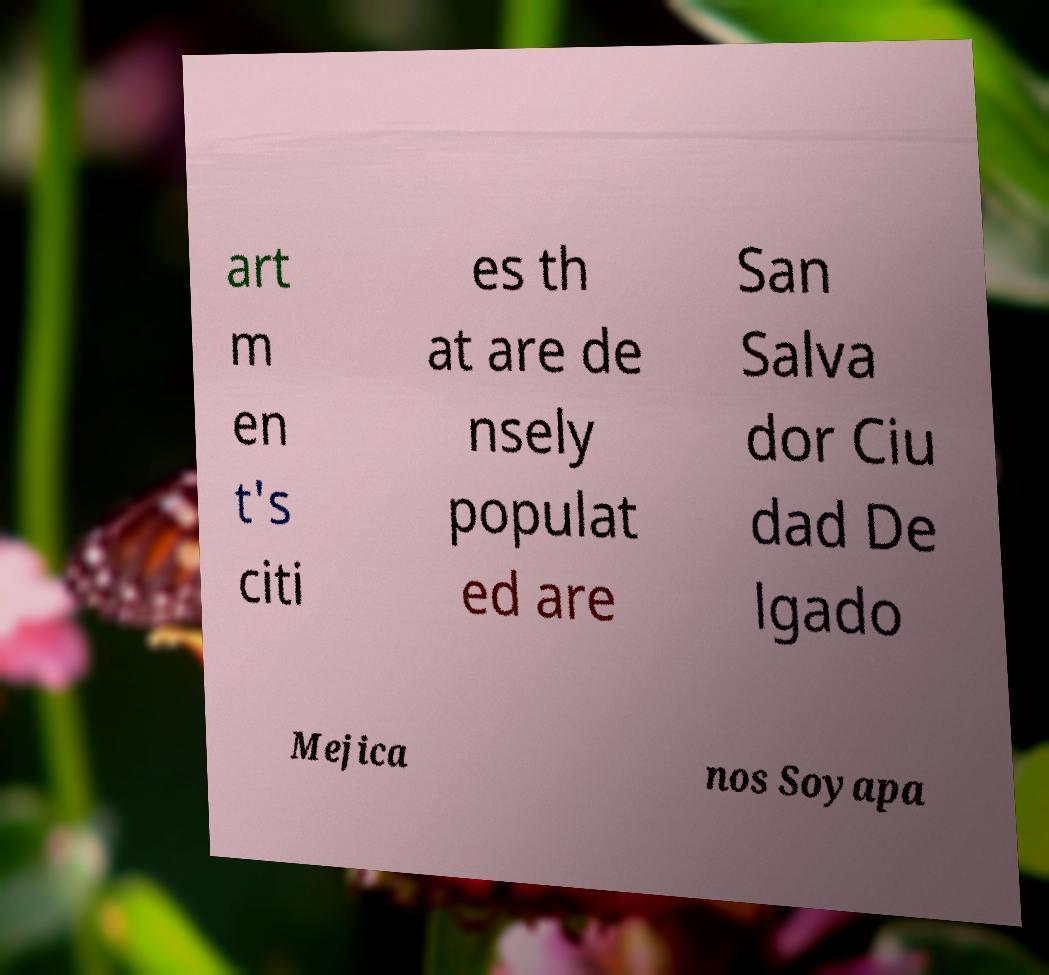There's text embedded in this image that I need extracted. Can you transcribe it verbatim? art m en t's citi es th at are de nsely populat ed are San Salva dor Ciu dad De lgado Mejica nos Soyapa 